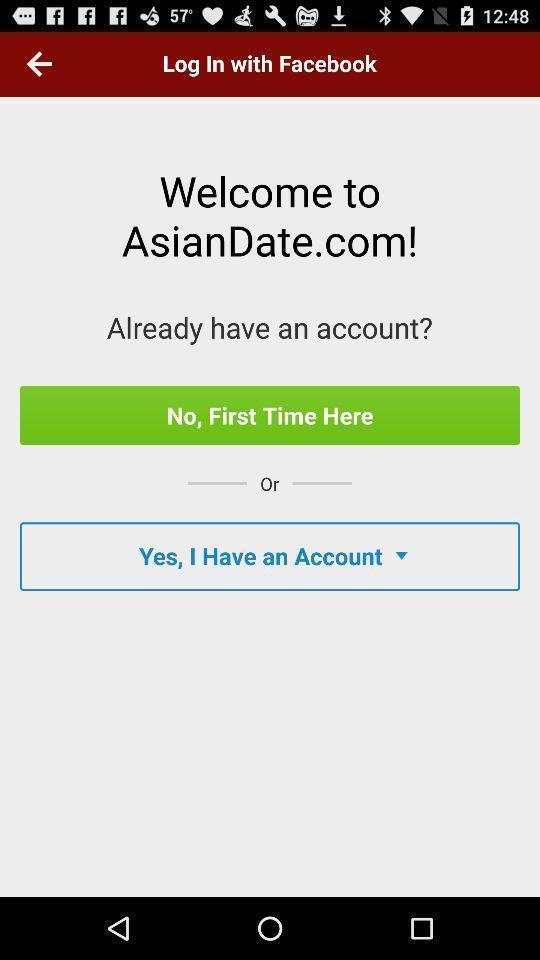Describe the content in this image. Welcome page with login details in a social app. 